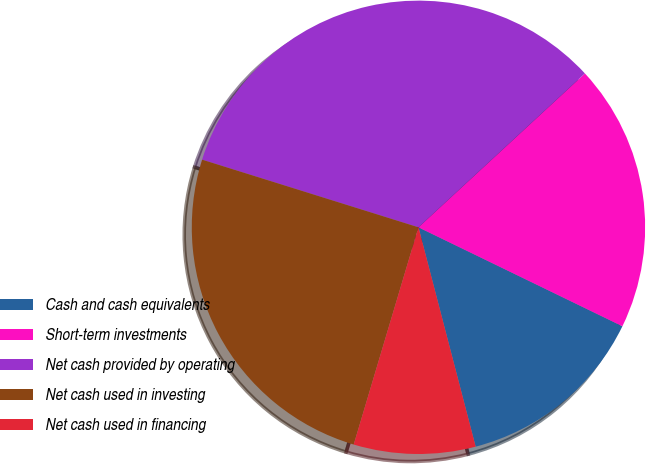Convert chart. <chart><loc_0><loc_0><loc_500><loc_500><pie_chart><fcel>Cash and cash equivalents<fcel>Short-term investments<fcel>Net cash provided by operating<fcel>Net cash used in investing<fcel>Net cash used in financing<nl><fcel>13.75%<fcel>19.06%<fcel>33.3%<fcel>25.21%<fcel>8.67%<nl></chart> 